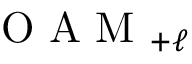Convert formula to latex. <formula><loc_0><loc_0><loc_500><loc_500>O A M _ { + \ell }</formula> 